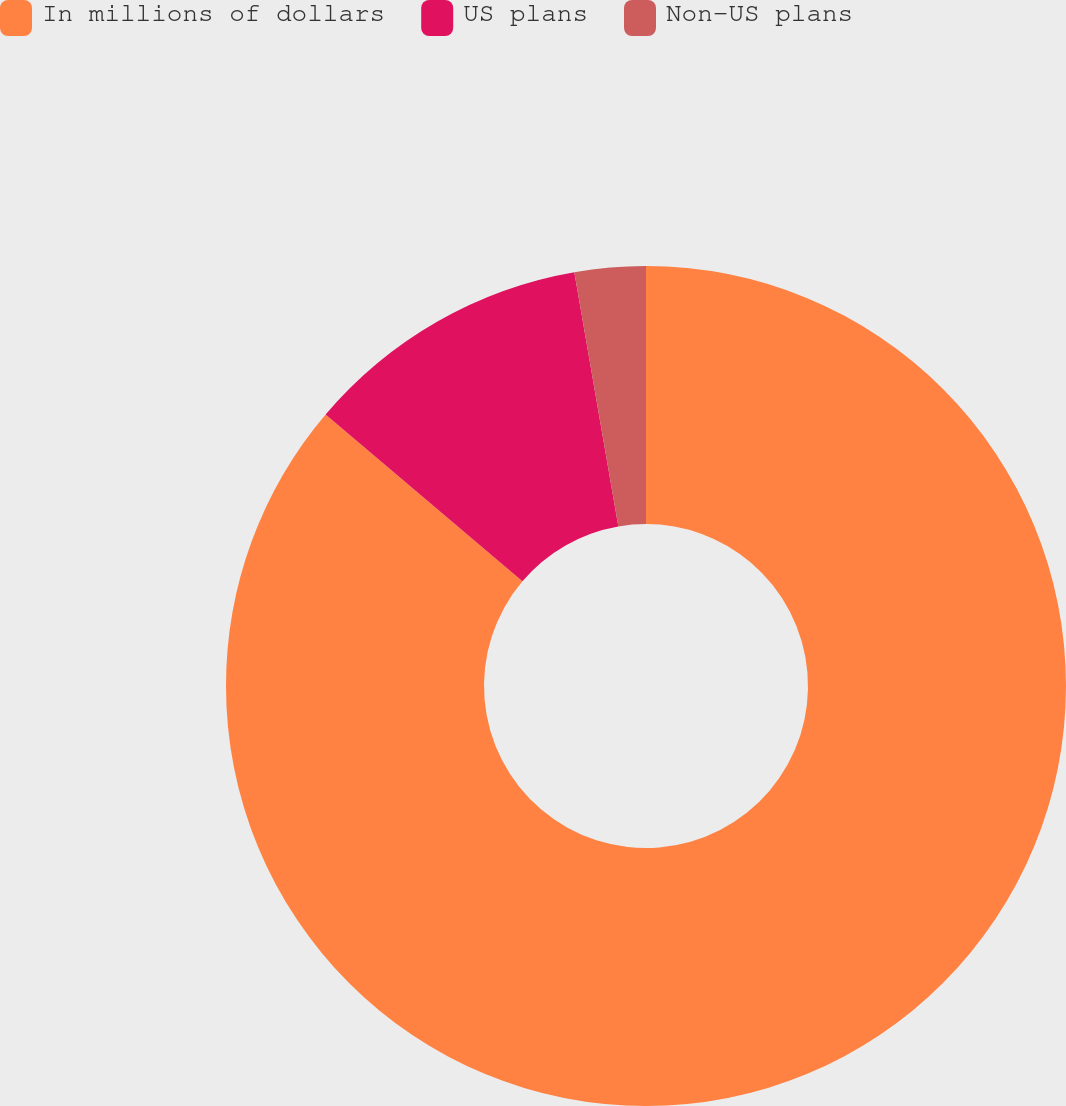Convert chart to OTSL. <chart><loc_0><loc_0><loc_500><loc_500><pie_chart><fcel>In millions of dollars<fcel>US plans<fcel>Non-US plans<nl><fcel>86.19%<fcel>11.08%<fcel>2.73%<nl></chart> 